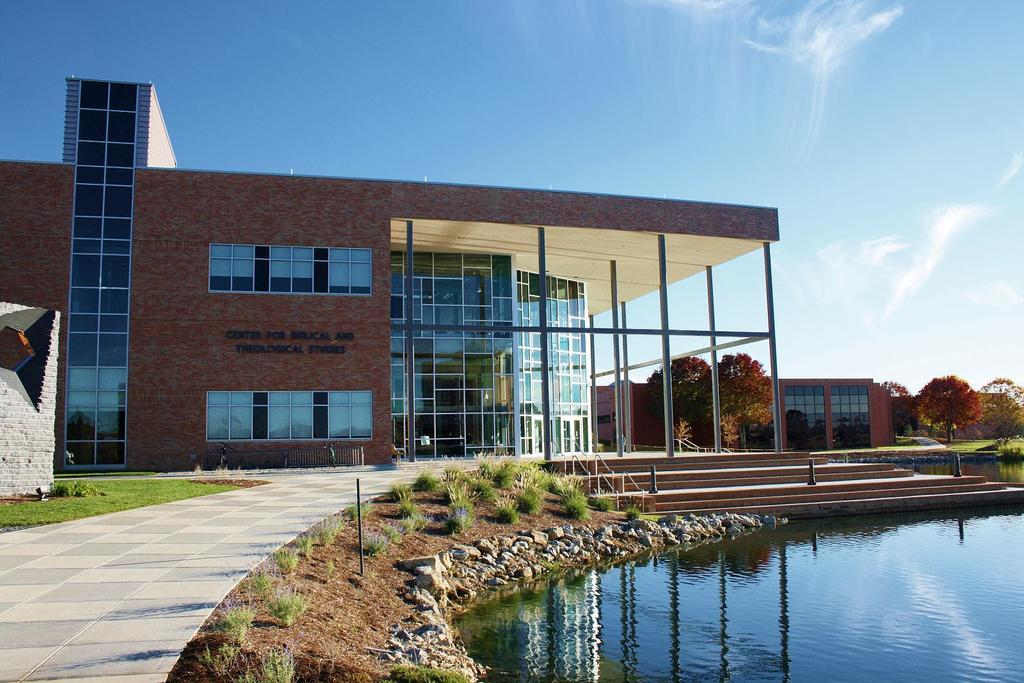How many buildings can be seen in the image? There are two buildings in the image. What type of terrain is visible in the image? There is grass visible in the image. What other elements can be seen in the image besides the buildings? Stones, water, stairs, fences, small poles, people, trees, and the sky are visible in the image. Where is the throne located in the image? There is no throne present in the image. What type of wilderness can be seen in the image? The image does not depict a wilderness setting; it features buildings, grass, water, and other elements. 